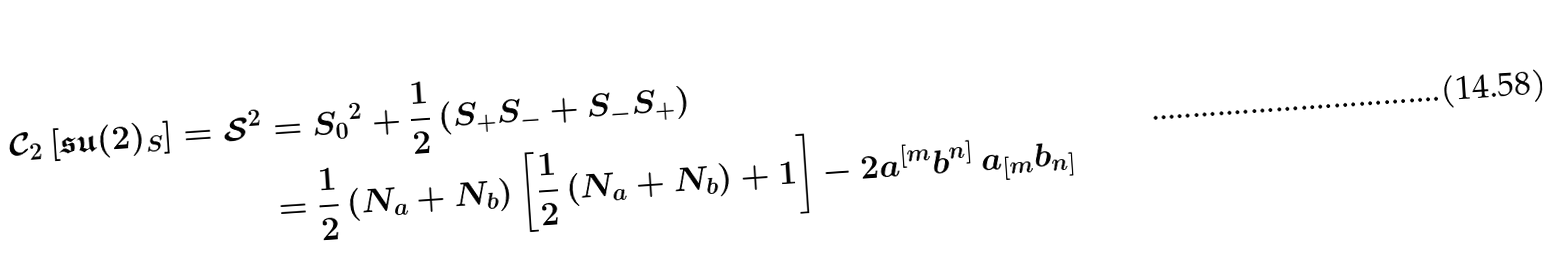Convert formula to latex. <formula><loc_0><loc_0><loc_500><loc_500>\mathcal { C } _ { 2 } \left [ \mathfrak { s u } ( 2 ) _ { S } \right ] = \mathcal { S } ^ { 2 } & = { S _ { 0 } } ^ { 2 } + \frac { 1 } { 2 } \left ( S _ { + } S _ { - } + S _ { - } S _ { + } \right ) \\ & = \frac { 1 } { 2 } \left ( N _ { a } + N _ { b } \right ) \left [ \frac { 1 } { 2 } \left ( N _ { a } + N _ { b } \right ) + 1 \right ] - 2 a ^ { [ m } b ^ { n ] } \, a _ { [ m } b _ { n ] }</formula> 